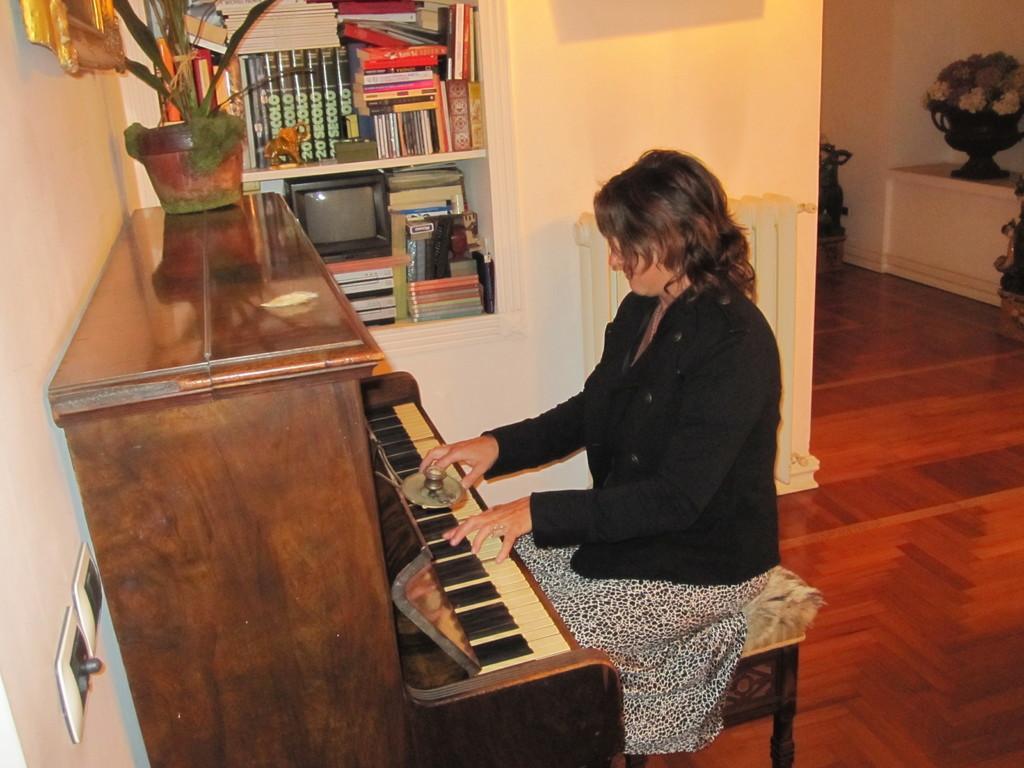How would you summarize this image in a sentence or two? In this image I can see a woman sitting on the stool and playing the piano. This is an image clicked inside the room. In the background there is a rack filled with books. On the right side there is a table on that I can see a flower pot. 